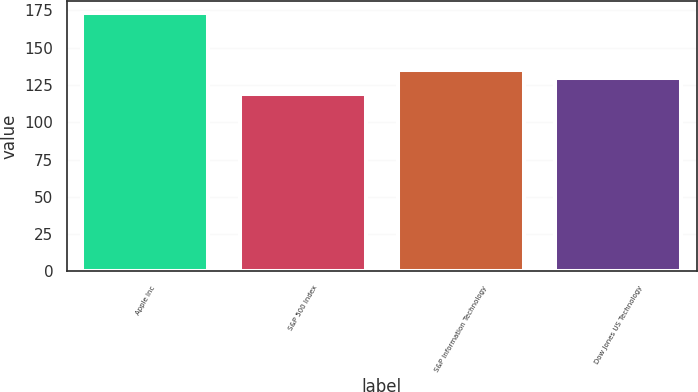<chart> <loc_0><loc_0><loc_500><loc_500><bar_chart><fcel>Apple Inc<fcel>S&P 500 Index<fcel>S&P Information Technology<fcel>Dow Jones US Technology<nl><fcel>173<fcel>119<fcel>135.4<fcel>130<nl></chart> 